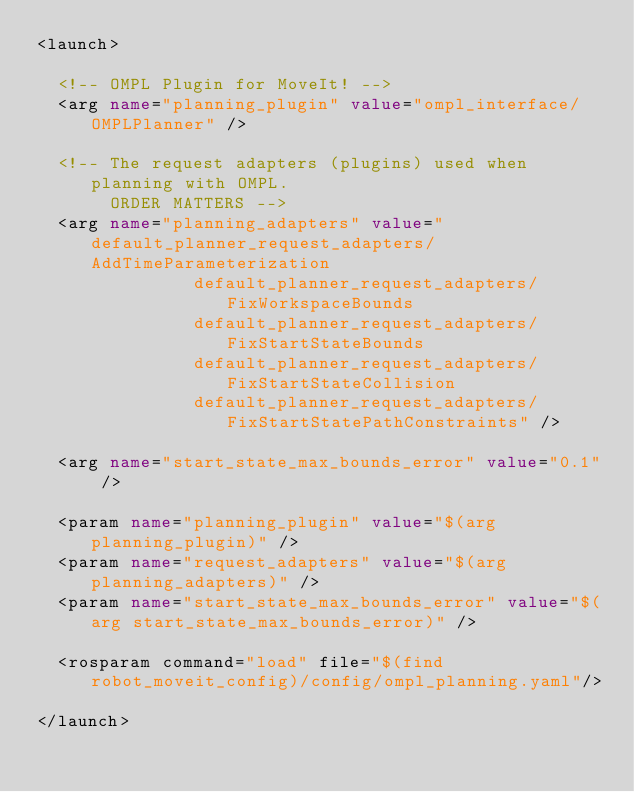<code> <loc_0><loc_0><loc_500><loc_500><_XML_><launch>

  <!-- OMPL Plugin for MoveIt! -->
  <arg name="planning_plugin" value="ompl_interface/OMPLPlanner" />

  <!-- The request adapters (plugins) used when planning with OMPL.
       ORDER MATTERS -->
  <arg name="planning_adapters" value="default_planner_request_adapters/AddTimeParameterization
				       default_planner_request_adapters/FixWorkspaceBounds
				       default_planner_request_adapters/FixStartStateBounds
				       default_planner_request_adapters/FixStartStateCollision
				       default_planner_request_adapters/FixStartStatePathConstraints" />

  <arg name="start_state_max_bounds_error" value="0.1" />

  <param name="planning_plugin" value="$(arg planning_plugin)" />
  <param name="request_adapters" value="$(arg planning_adapters)" />
  <param name="start_state_max_bounds_error" value="$(arg start_state_max_bounds_error)" />

  <rosparam command="load" file="$(find robot_moveit_config)/config/ompl_planning.yaml"/>

</launch>
</code> 